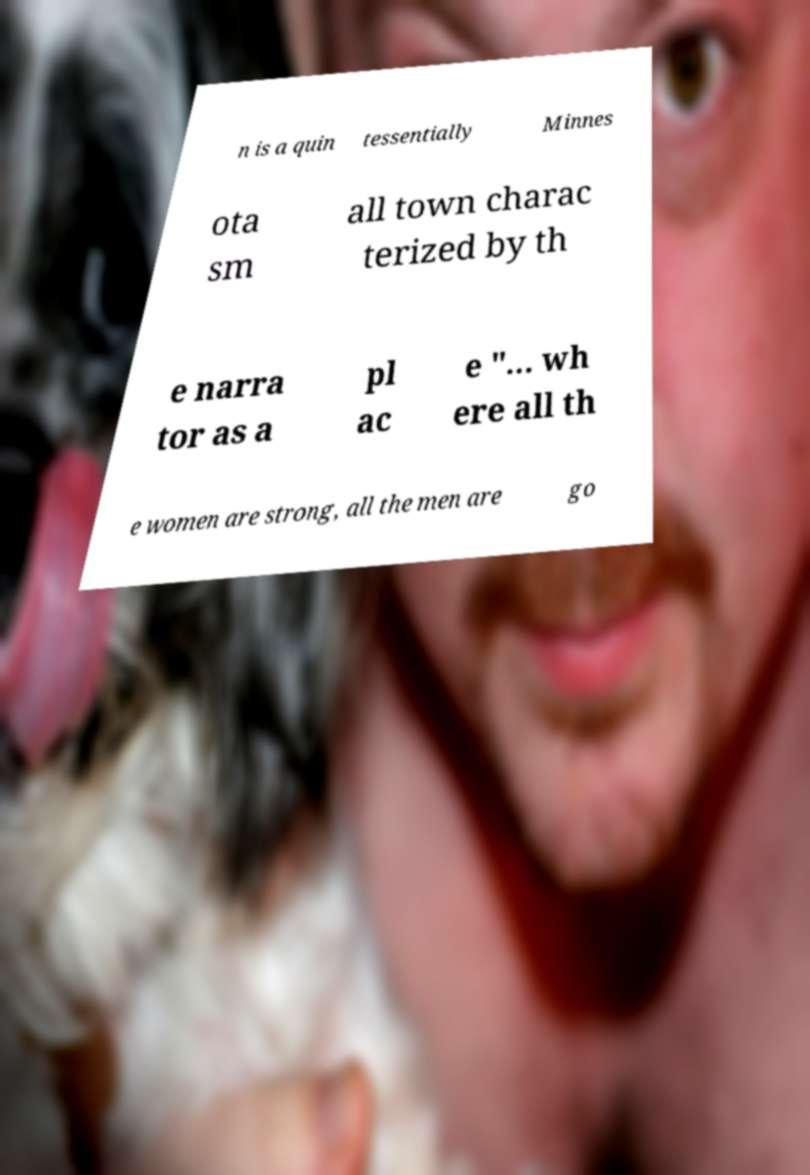Could you assist in decoding the text presented in this image and type it out clearly? n is a quin tessentially Minnes ota sm all town charac terized by th e narra tor as a pl ac e "... wh ere all th e women are strong, all the men are go 